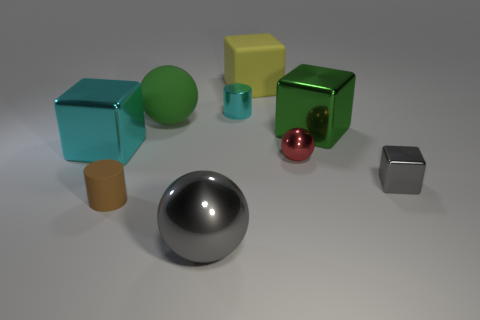Subtract all metal spheres. How many spheres are left? 1 Subtract all spheres. How many objects are left? 6 Subtract all gray blocks. How many blocks are left? 3 Subtract all yellow cubes. Subtract all red cylinders. How many cubes are left? 3 Subtract all gray objects. Subtract all tiny red things. How many objects are left? 6 Add 6 tiny red shiny things. How many tiny red shiny things are left? 7 Add 5 small brown objects. How many small brown objects exist? 6 Subtract 0 gray cylinders. How many objects are left? 9 